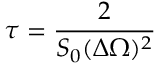<formula> <loc_0><loc_0><loc_500><loc_500>\tau = \frac { 2 } { S _ { 0 } ( \Delta \Omega ) ^ { 2 } }</formula> 